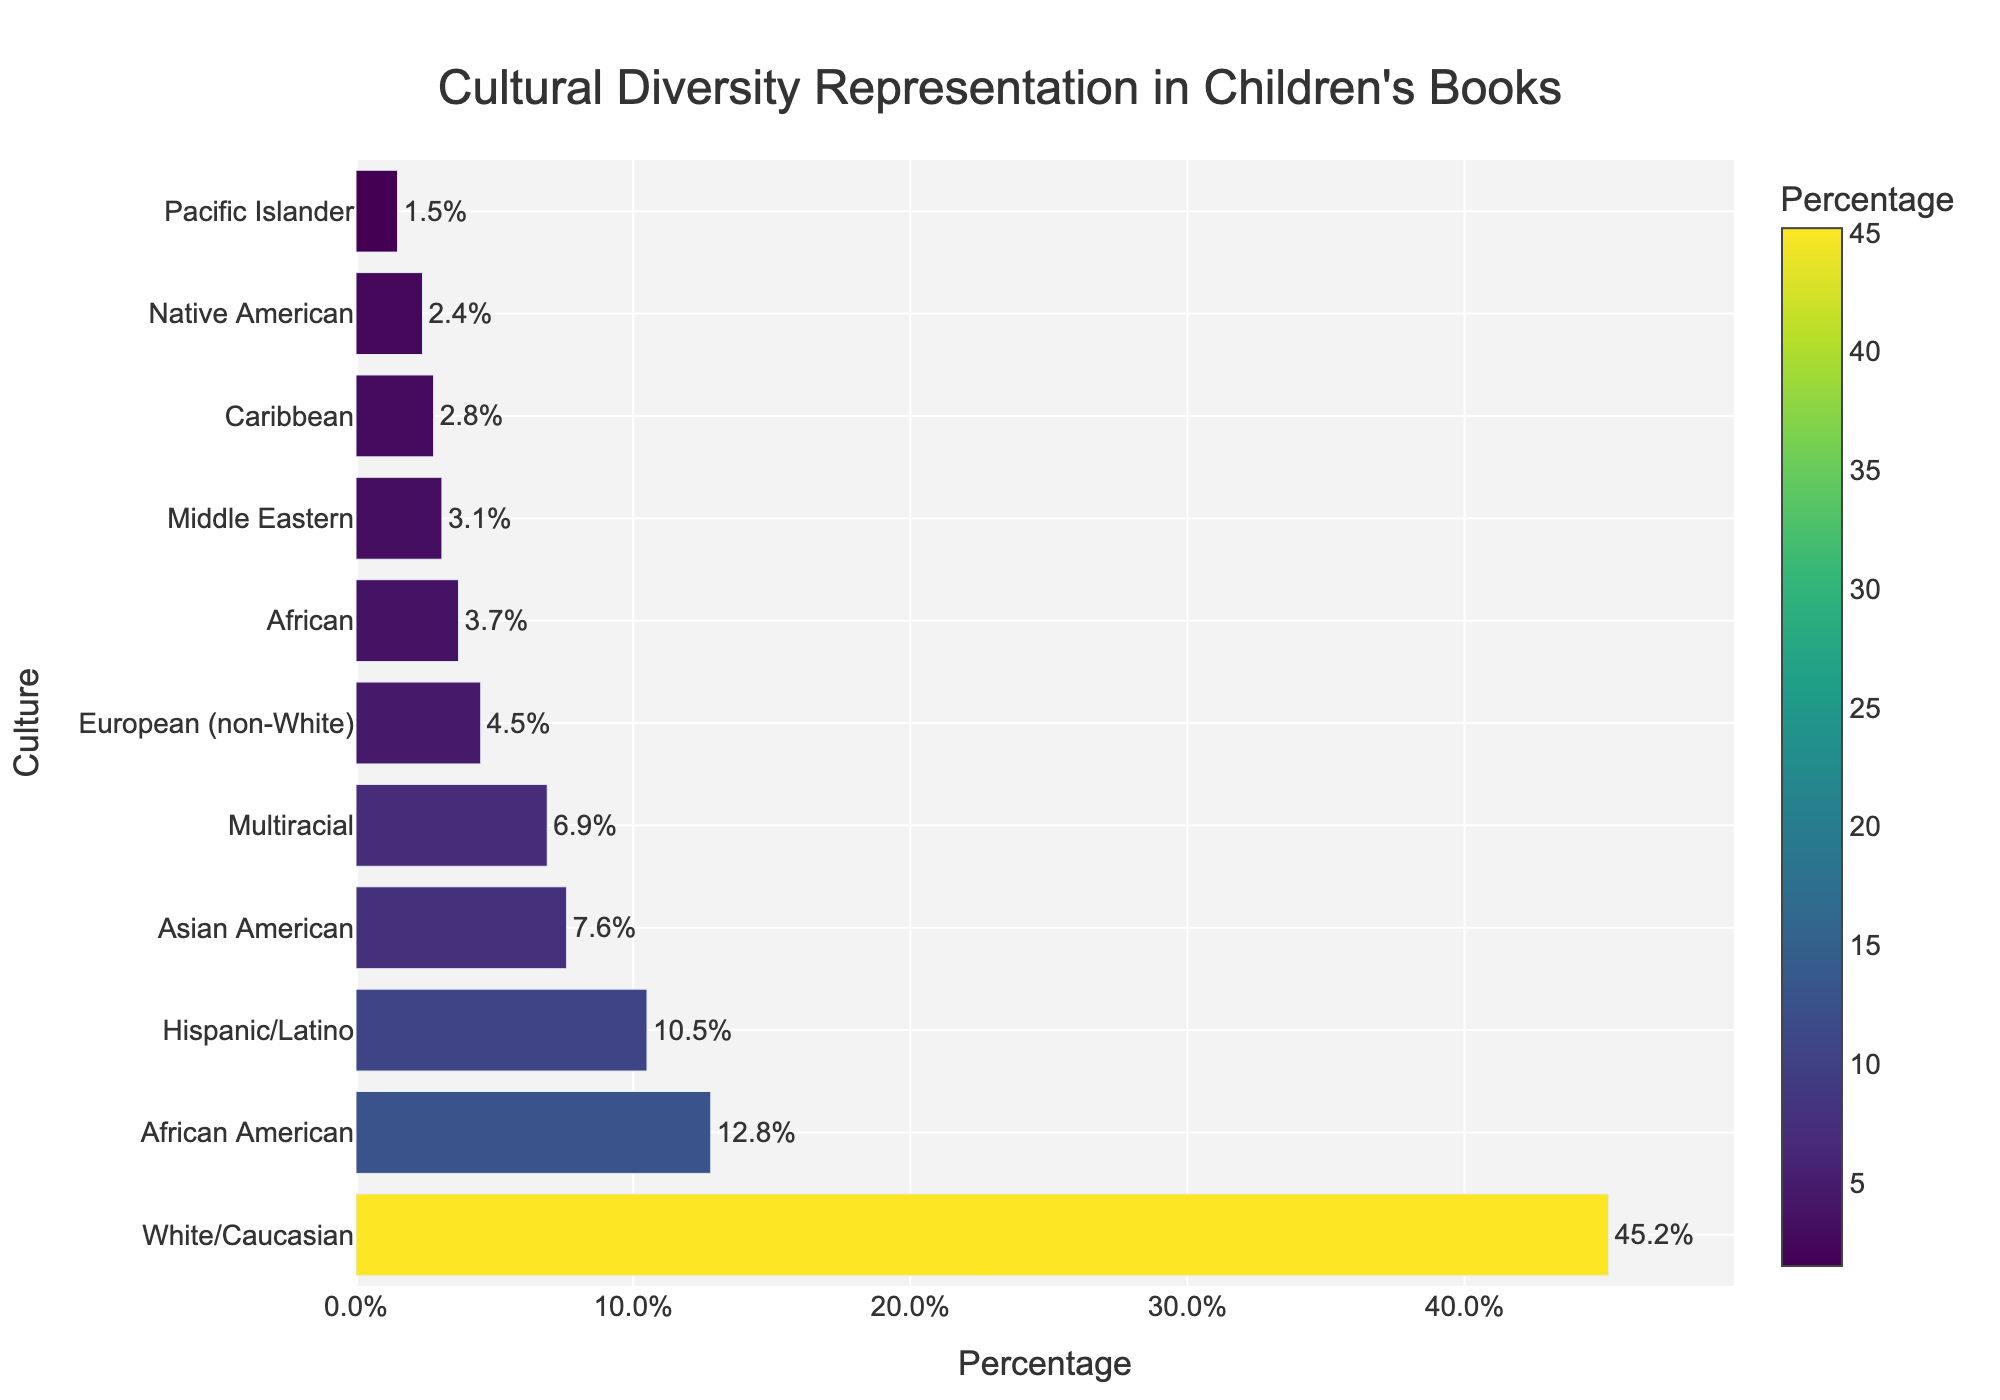Which culture is represented the most in children's books at the local library? The bar for "White/Caucasian" is the longest, indicating it has the highest percentage.
Answer: White/Caucasian How many cultures have a representation of 10% or higher? The bars for "White/Caucasian", "African American", and "Hispanic/Latino" extend to 45.2%, 12.8%, and 10.5% respectively, which are all 10% or higher.
Answer: 3 What is the combined percentage of African American and Asian American representation? The percentages for "African American" and "Asian American" are 12.8% and 7.6% respectively. Adding them gives 12.8 + 7.6 = 20.4%.
Answer: 20.4% Which cultures have less than 5% representation? The bars for "Native American", "Middle Eastern", "Pacific Islander", "Caribbean", and "European (non-White)" extend to 2.4%, 3.1%, 1.5%, 2.8%, and 4.5% respectively, all below 5%.
Answer: Native American, Middle Eastern, Pacific Islander, Caribbean, European (non-White) Does Multiracial representation exceed African representation? The bar for "Multiracial" is longer than the bar for "African", indicating a higher percentage (6.9% vs 3.7%).
Answer: Yes What's the difference in percentage between the most and least represented cultures? The most represented culture is "White/Caucasian" with 45.2%, and the least represented is "Pacific Islander" with 1.5%. The difference is 45.2 - 1.5 = 43.7%.
Answer: 43.7% Which cultures fall in the middle percentile range between 5% and 10%? The bars for "Multiracial" and "Asian American" extend to 6.9% and 7.6% respectively, falling between 5% and 10%.
Answer: Multiracial, Asian American What is the average percentage representation of all cultures? Sum all percentages: 45.2 + 12.8 + 10.5 + 7.6 + 2.4 + 3.1 + 6.9 + 1.5 + 2.8 + 3.7 + 4.5 = 101.0. There are 11 cultures, so the average is 101.0 / 11 ≈ 9.18%.
Answer: 9.18% Are there more cultures with less than 5% representation or more than 5% representation? Cultures with less than 5% are "Native American", "Middle Eastern", "Pacific Islander", "Caribbean", and "European (non-White)" (5 cultures). More than 5% are "White/Caucasian", "African American", "Hispanic/Latino", "Asian American", and "Multiracial" (5 cultures).
Answer: Equal number 